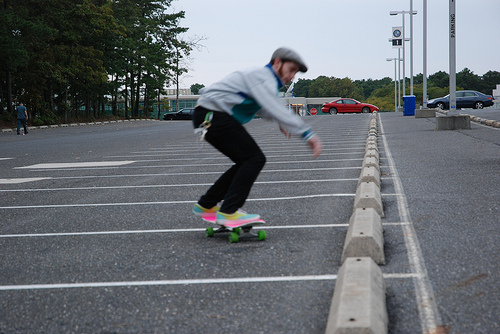Can you tell what time of the day it is? Based on the lighting and lack of shadows, it seems like the photo was taken on an overcast day, possibly in the earlier to mid hours when the sun is not at its peak. 